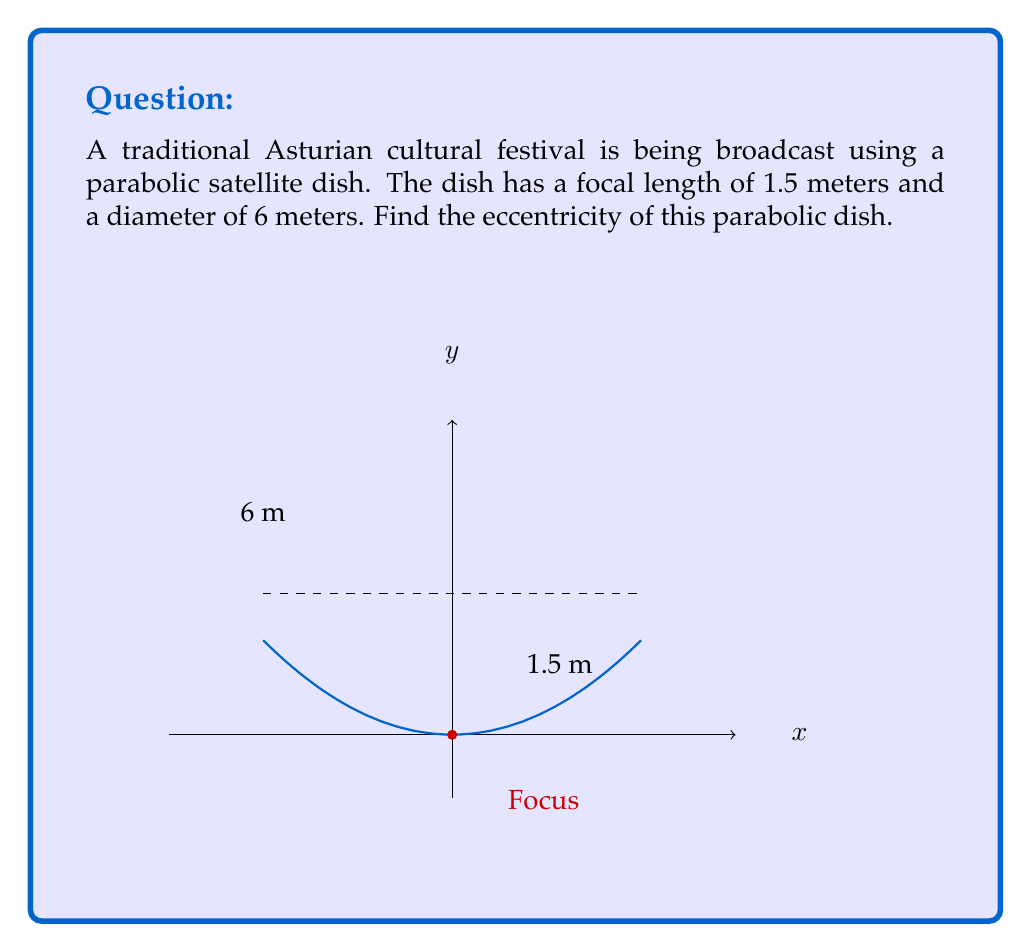Could you help me with this problem? Let's approach this step-by-step:

1) The eccentricity of a parabola is always 1. However, we can prove this using the given information.

2) For a parabola, the eccentricity $e$ is related to the focal length $f$ and the latus rectum $l$ by the formula:

   $$e = \sqrt{1 + \frac{4f}{l}}$$

3) We know the focal length $f = 1.5$ meters. We need to find the latus rectum.

4) For a parabola, the latus rectum is given by $l = \frac{D^2}{4f}$, where $D$ is the diameter of the dish.

5) We have $D = 6$ meters, so:

   $$l = \frac{6^2}{4(1.5)} = \frac{36}{6} = 6\text{ meters}$$

6) Now we can substitute these values into our eccentricity formula:

   $$e = \sqrt{1 + \frac{4f}{l}} = \sqrt{1 + \frac{4(1.5)}{6}} = \sqrt{1 + 1} = \sqrt{2} = 1$$

7) This confirms that the eccentricity of the parabolic dish is indeed 1.
Answer: $1$ 